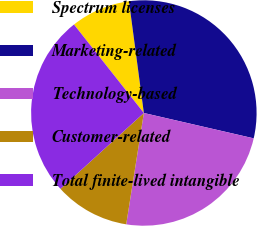<chart> <loc_0><loc_0><loc_500><loc_500><pie_chart><fcel>Spectrum licenses<fcel>Marketing-related<fcel>Technology-based<fcel>Customer-related<fcel>Total finite-lived intangible<nl><fcel>8.53%<fcel>30.72%<fcel>23.89%<fcel>10.75%<fcel>26.11%<nl></chart> 